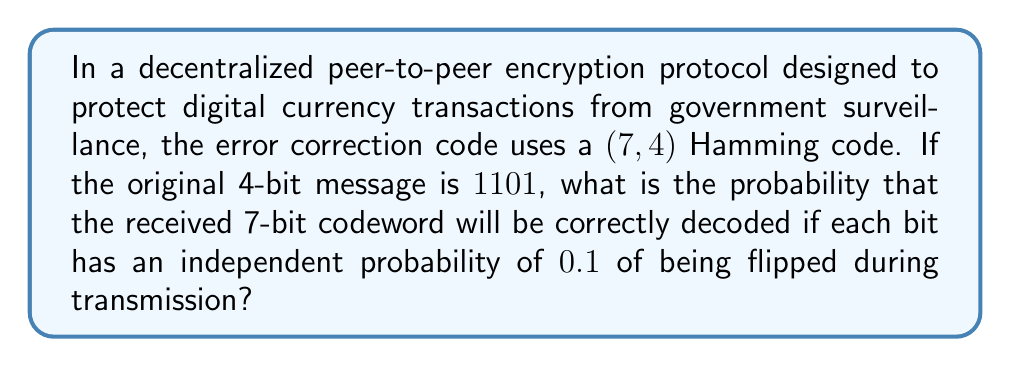Help me with this question. Let's approach this step-by-step:

1) First, we need to understand what a $(7,4)$ Hamming code does. It takes a 4-bit message and adds 3 parity bits to create a 7-bit codeword. This code can correct any single-bit error.

2) The original message $1101$ will be encoded into a 7-bit codeword. The exact codeword depends on the specific implementation, but for this problem, we don't need to know it.

3) For the codeword to be correctly decoded, we need either:
   a) No bits to be flipped, or
   b) Exactly one bit to be flipped (which the Hamming code can correct)

4) Let's calculate these probabilities:
   
   a) Probability of no bits being flipped:
      $$P(\text{no errors}) = 0.9^7 \approx 0.4783$$
   
   b) Probability of exactly one bit being flipped:
      $$P(\text{one error}) = \binom{7}{1} \cdot 0.1 \cdot 0.9^6 \approx 0.3874$$

5) The total probability of correct decoding is the sum of these probabilities:

   $$P(\text{correct}) = P(\text{no errors}) + P(\text{one error})$$
   $$P(\text{correct}) = 0.4783 + 0.3874 = 0.8657$$

Therefore, the probability that the received 7-bit codeword will be correctly decoded is approximately 0.8657 or 86.57%.
Answer: 0.8657 or 86.57% 